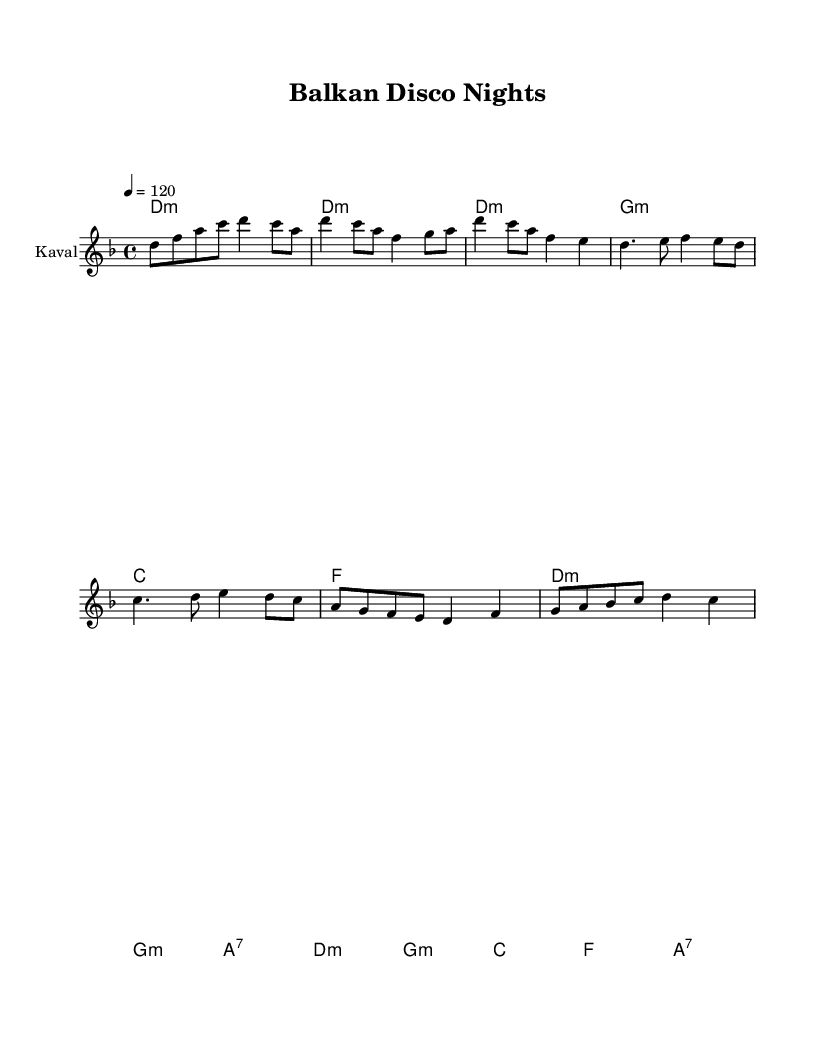What is the key signature of this music? The key signature is indicated at the beginning of the staff. In this case, it shows two flats, which corresponds to D minor.
Answer: D minor What is the time signature of this music? The time signature is shown at the beginning of the staff, presented as a fraction. Here, it is 4 over 4, indicating four beats per measure.
Answer: 4/4 What is the tempo marking for this piece? The tempo marking is depicted at the beginning with a note value and a metronome marking. In this case, it indicates "4 = 120", meaning quarter note equals 120 beats per minute.
Answer: 120 How many measures are in the verse section? The verse section can be deduced by analyzing the score layout. The verse goes through two lines of music, with each line typically containing four measures, resulting in eight measures together.
Answer: 8 Which instrument is featured in this piece? The score specifies the instrument name directly associated with the staff, which is denoted in the staff header. It is labeled as "Kaval," a traditional wind instrument.
Answer: Kaval What chords are used in the chorus? By examining the chord changes during the chorus section of the score, the listed chords are D minor, G minor, A7, and back to D minor. These are derived from the chord symbols written above the melody line.
Answer: D minor, G minor, A7, D minor What rhythm pattern is primarily used in the melody? By analyzing the rhythm notations in the melody, it becomes evident that the melody frequently alternates between eighth notes and quarter notes, creating a lively disco feel typical for dance music.
Answer: Eighth and quarter notes 